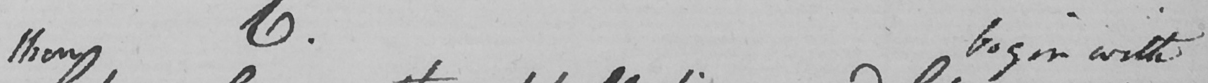What does this handwritten line say? then begin with 